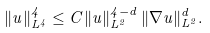<formula> <loc_0><loc_0><loc_500><loc_500>\| u \| _ { L ^ { 4 } } ^ { 4 } \leq C \| u \| _ { L ^ { 2 } } ^ { 4 - d } \, \| \nabla u \| _ { L ^ { 2 } } ^ { d } .</formula> 